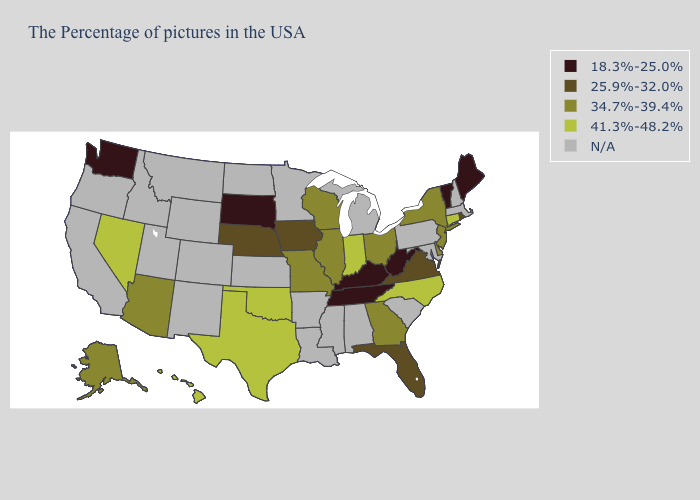Name the states that have a value in the range 34.7%-39.4%?
Be succinct. New York, New Jersey, Delaware, Ohio, Georgia, Wisconsin, Illinois, Missouri, Arizona, Alaska. Does Washington have the lowest value in the West?
Concise answer only. Yes. Does the first symbol in the legend represent the smallest category?
Concise answer only. Yes. What is the lowest value in the Northeast?
Answer briefly. 18.3%-25.0%. Does Washington have the lowest value in the West?
Quick response, please. Yes. What is the value of Wyoming?
Write a very short answer. N/A. Does Hawaii have the highest value in the USA?
Quick response, please. Yes. Name the states that have a value in the range 25.9%-32.0%?
Be succinct. Rhode Island, Virginia, Florida, Iowa, Nebraska. Does Indiana have the highest value in the MidWest?
Concise answer only. Yes. Which states have the highest value in the USA?
Answer briefly. Connecticut, North Carolina, Indiana, Oklahoma, Texas, Nevada, Hawaii. Is the legend a continuous bar?
Give a very brief answer. No. Among the states that border Utah , does Nevada have the lowest value?
Answer briefly. No. Which states have the lowest value in the USA?
Quick response, please. Maine, Vermont, West Virginia, Kentucky, Tennessee, South Dakota, Washington. 